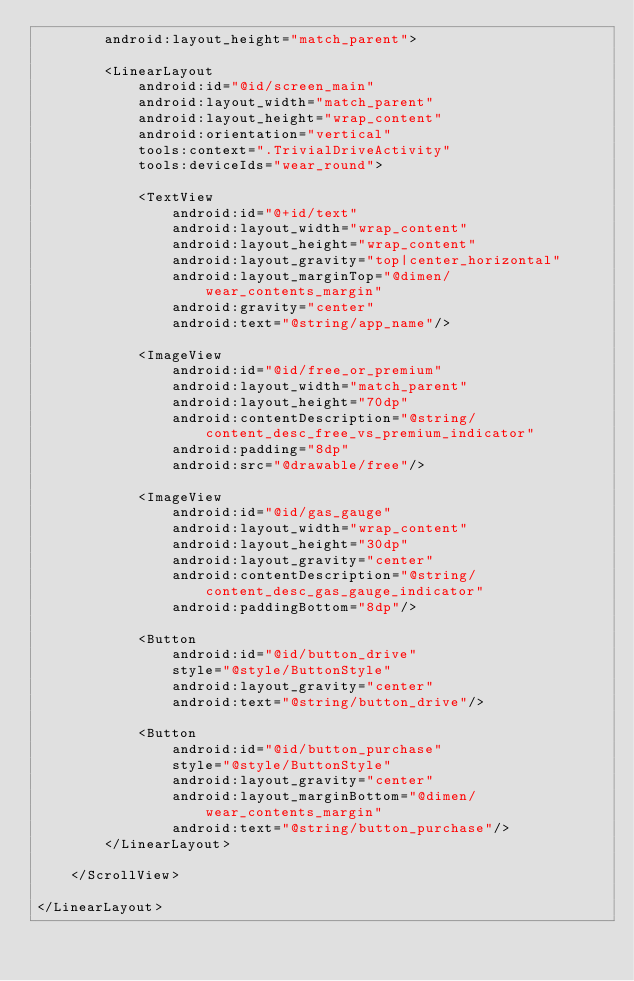<code> <loc_0><loc_0><loc_500><loc_500><_XML_>        android:layout_height="match_parent">

        <LinearLayout
            android:id="@id/screen_main"
            android:layout_width="match_parent"
            android:layout_height="wrap_content"
            android:orientation="vertical"
            tools:context=".TrivialDriveActivity"
            tools:deviceIds="wear_round">

            <TextView
                android:id="@+id/text"
                android:layout_width="wrap_content"
                android:layout_height="wrap_content"
                android:layout_gravity="top|center_horizontal"
                android:layout_marginTop="@dimen/wear_contents_margin"
                android:gravity="center"
                android:text="@string/app_name"/>

            <ImageView
                android:id="@id/free_or_premium"
                android:layout_width="match_parent"
                android:layout_height="70dp"
                android:contentDescription="@string/content_desc_free_vs_premium_indicator"
                android:padding="8dp"
                android:src="@drawable/free"/>

            <ImageView
                android:id="@id/gas_gauge"
                android:layout_width="wrap_content"
                android:layout_height="30dp"
                android:layout_gravity="center"
                android:contentDescription="@string/content_desc_gas_gauge_indicator"
                android:paddingBottom="8dp"/>

            <Button
                android:id="@id/button_drive"
                style="@style/ButtonStyle"
                android:layout_gravity="center"
                android:text="@string/button_drive"/>

            <Button
                android:id="@id/button_purchase"
                style="@style/ButtonStyle"
                android:layout_gravity="center"
                android:layout_marginBottom="@dimen/wear_contents_margin"
                android:text="@string/button_purchase"/>
        </LinearLayout>

    </ScrollView>

</LinearLayout></code> 